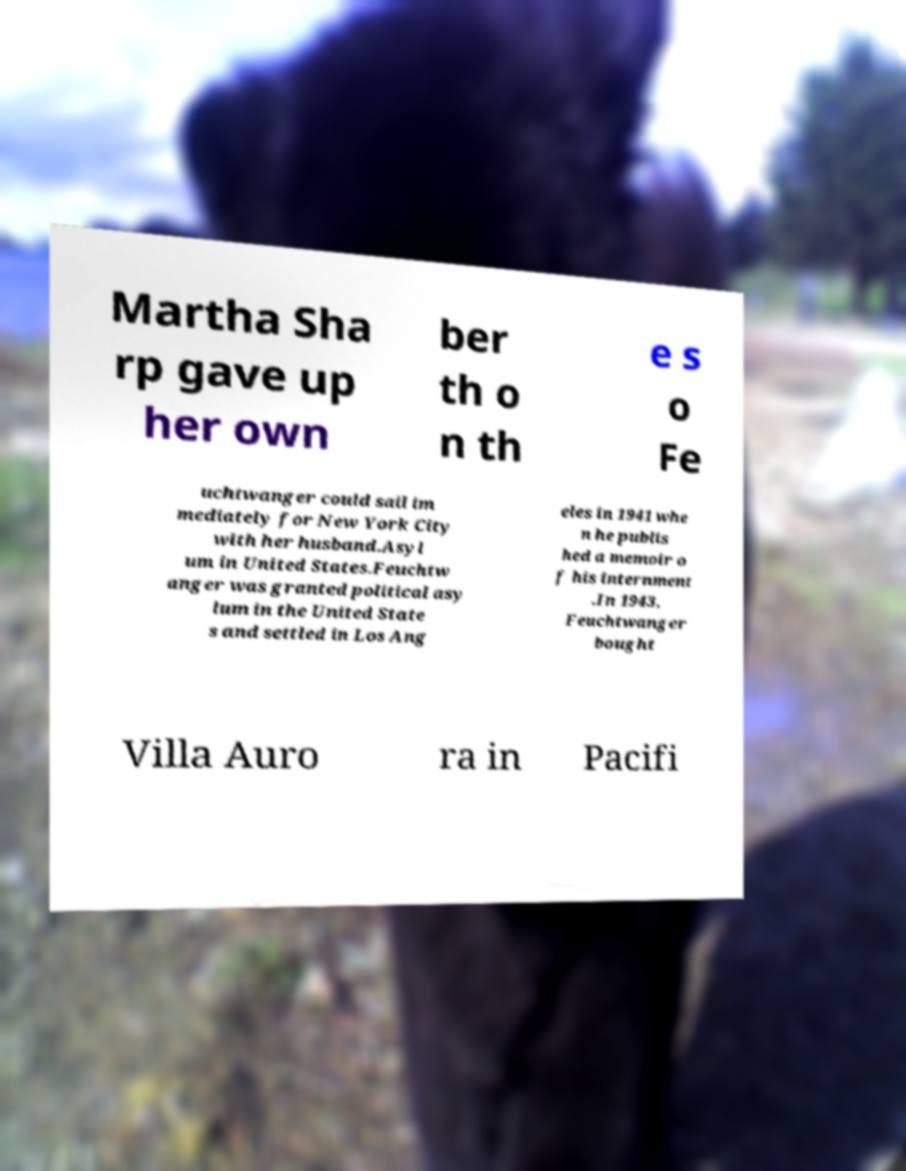What messages or text are displayed in this image? I need them in a readable, typed format. Martha Sha rp gave up her own ber th o n th e s o Fe uchtwanger could sail im mediately for New York City with her husband.Asyl um in United States.Feuchtw anger was granted political asy lum in the United State s and settled in Los Ang eles in 1941 whe n he publis hed a memoir o f his internment .In 1943, Feuchtwanger bought Villa Auro ra in Pacifi 